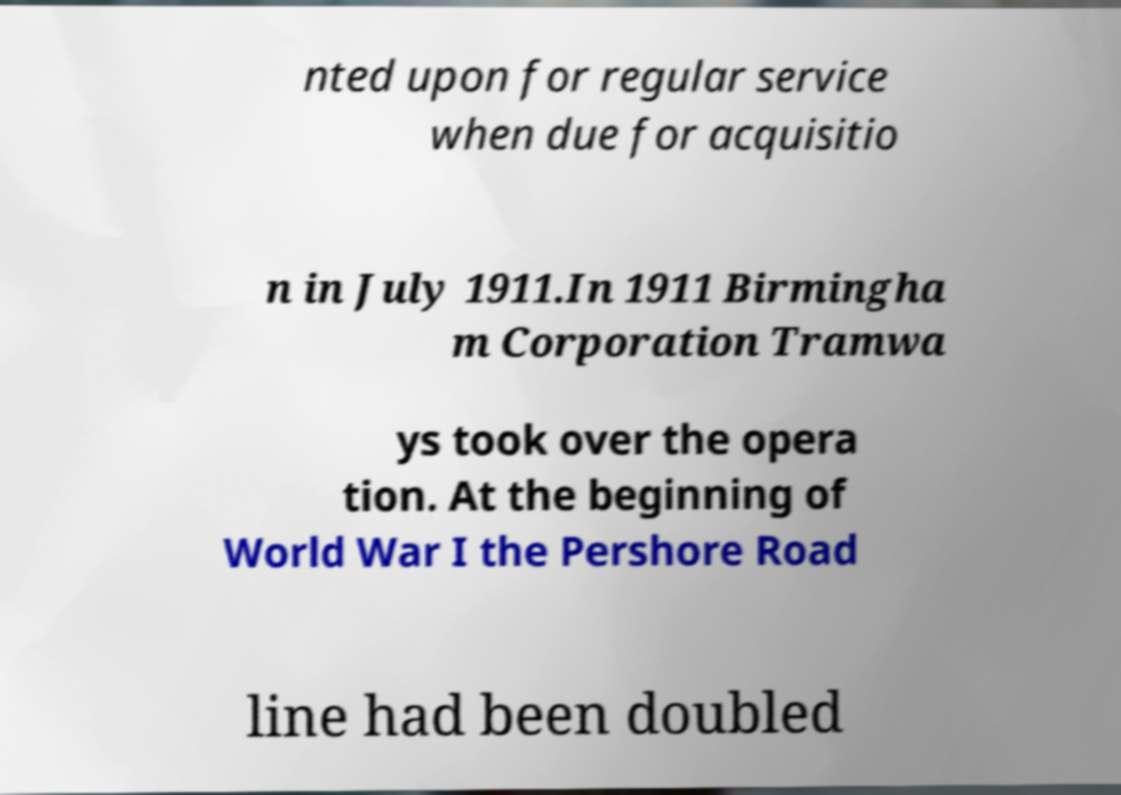Could you assist in decoding the text presented in this image and type it out clearly? nted upon for regular service when due for acquisitio n in July 1911.In 1911 Birmingha m Corporation Tramwa ys took over the opera tion. At the beginning of World War I the Pershore Road line had been doubled 